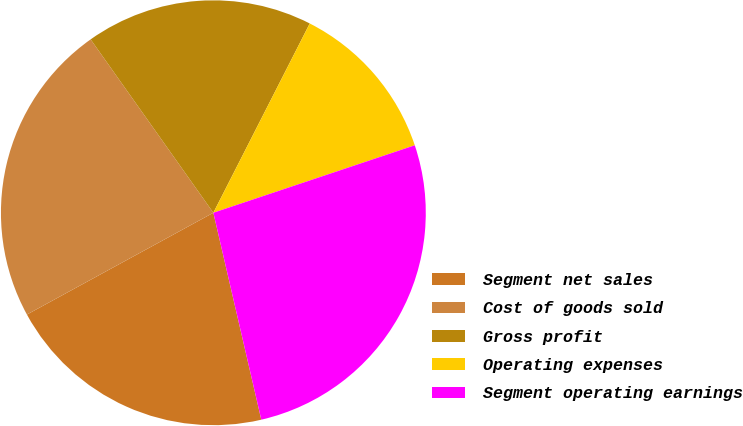<chart> <loc_0><loc_0><loc_500><loc_500><pie_chart><fcel>Segment net sales<fcel>Cost of goods sold<fcel>Gross profit<fcel>Operating expenses<fcel>Segment operating earnings<nl><fcel>20.67%<fcel>23.15%<fcel>17.3%<fcel>12.36%<fcel>26.52%<nl></chart> 